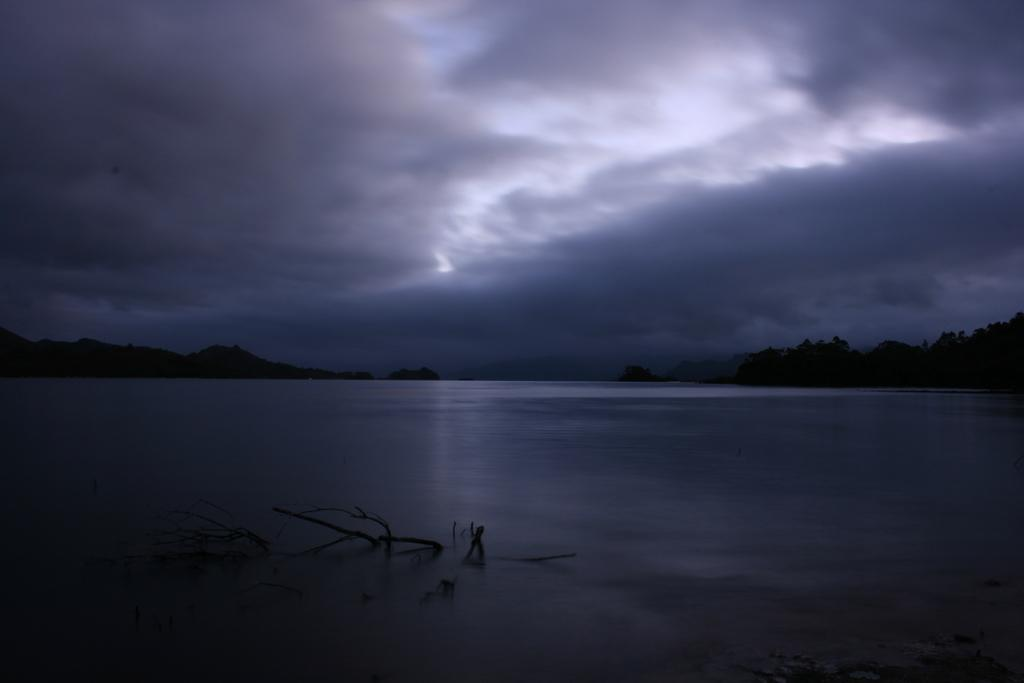What can be seen in the background of the image? The sky is visible in the image. What is the condition of the sky in the image? Clouds are present in the sky. What type of vegetation is visible in the image? There are trees in the image. What natural element is visible in the image? There is water visible in the image. Can you tell me how many nails are used to hold the tree trunk in the image? There are no nails present in the image, as it features natural elements such as the sky, clouds, trees, and water. What type of elephant can be seen interacting with the water in the image? There is no elephant present in the image; it only features natural elements. 